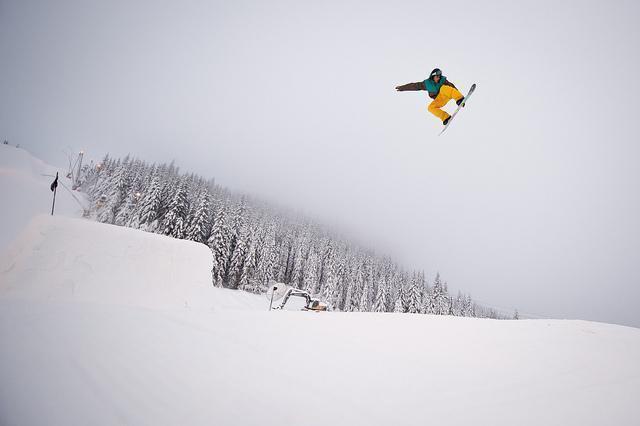How skilled is this skier in the activity?
Indicate the correct response and explain using: 'Answer: answer
Rationale: rationale.'
Options: Intermediate, professional, amateur, beginner. Answer: professional.
Rationale: The skier is doing a trick that is very complicated and dangerous and of the highest skill level. 